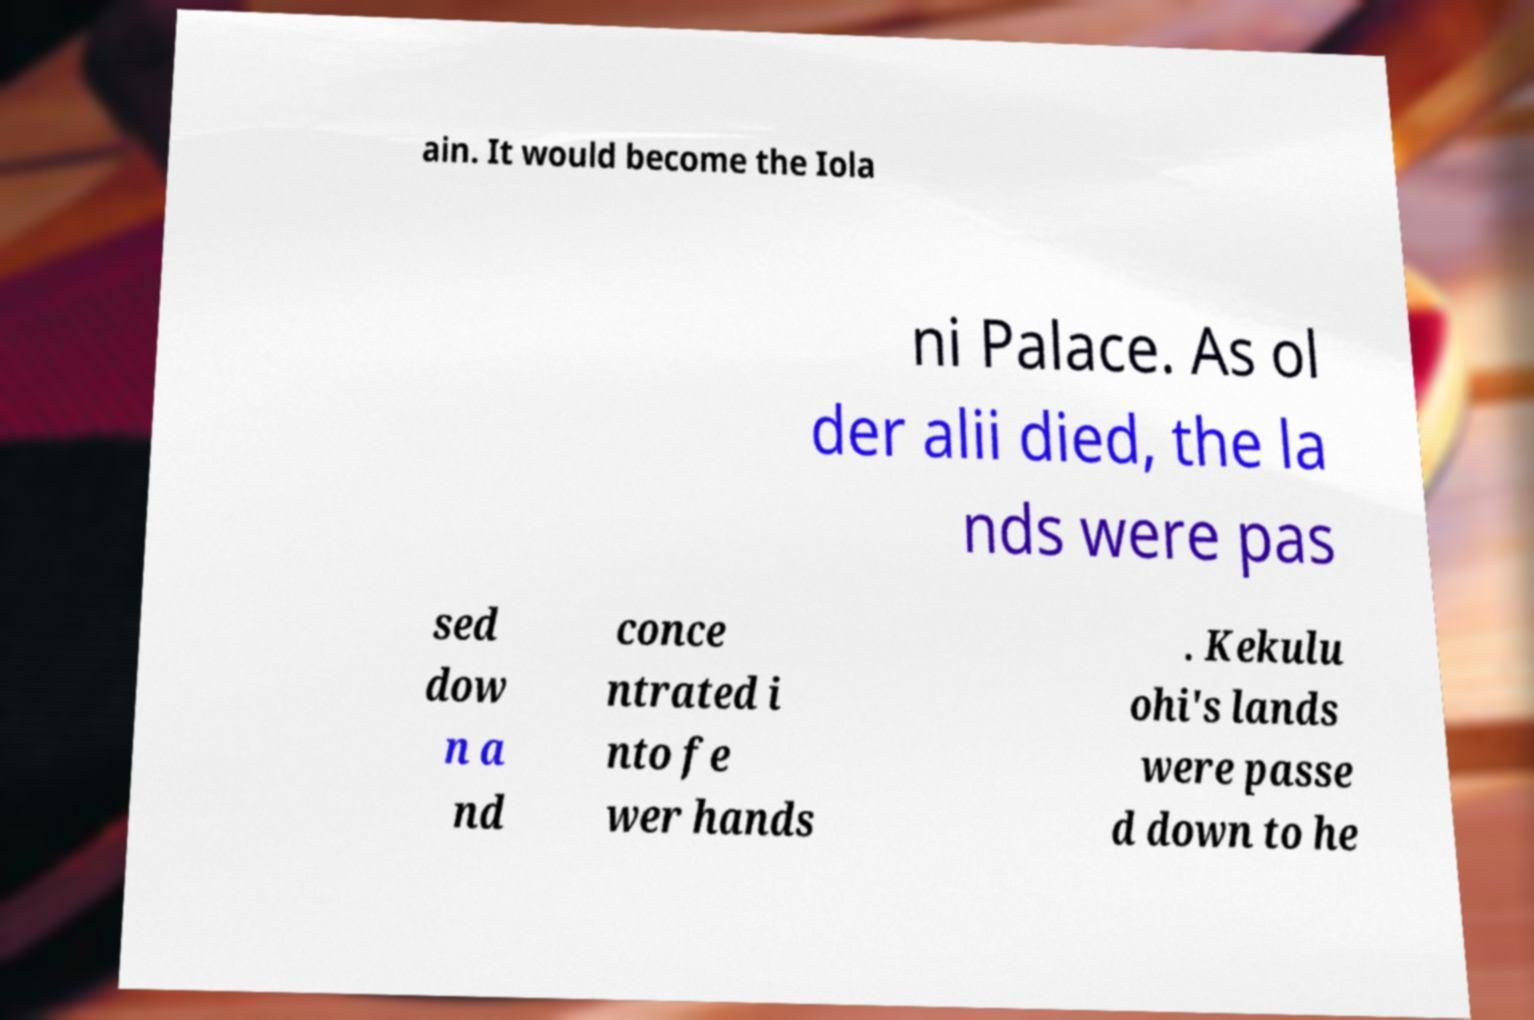For documentation purposes, I need the text within this image transcribed. Could you provide that? ain. It would become the Iola ni Palace. As ol der alii died, the la nds were pas sed dow n a nd conce ntrated i nto fe wer hands . Kekulu ohi's lands were passe d down to he 